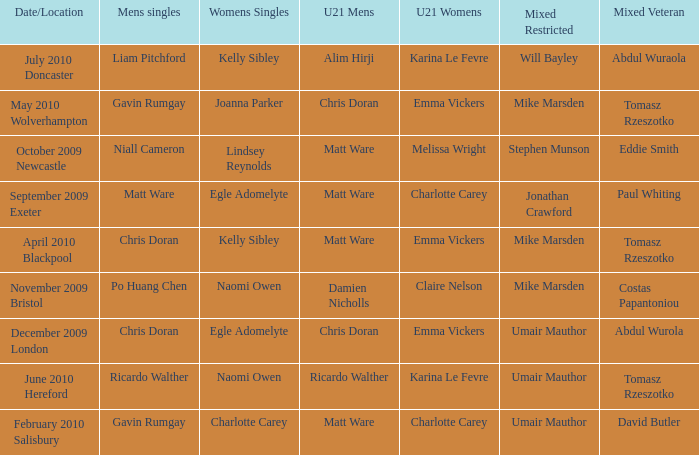When Naomi Owen won the Womens Singles and Ricardo Walther won the Mens Singles, who won the mixed veteran? Tomasz Rzeszotko. 